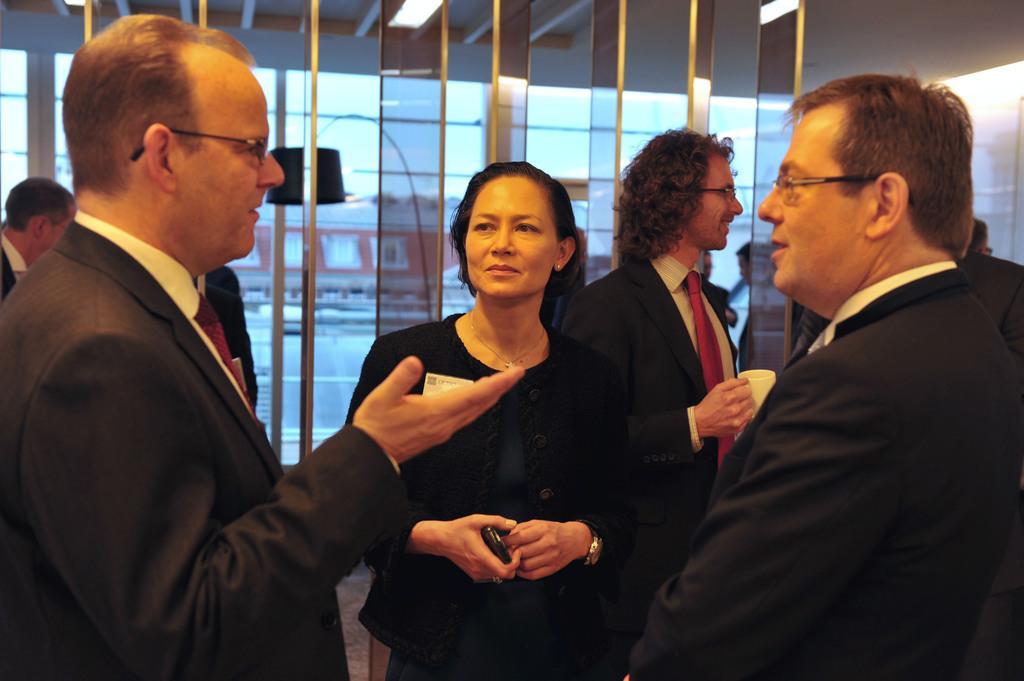In one or two sentences, can you explain what this image depicts? In this picture we can see a group of people standing on the floor and the man in the black blazer is holding a white cup. Behind the people there are glasses. 